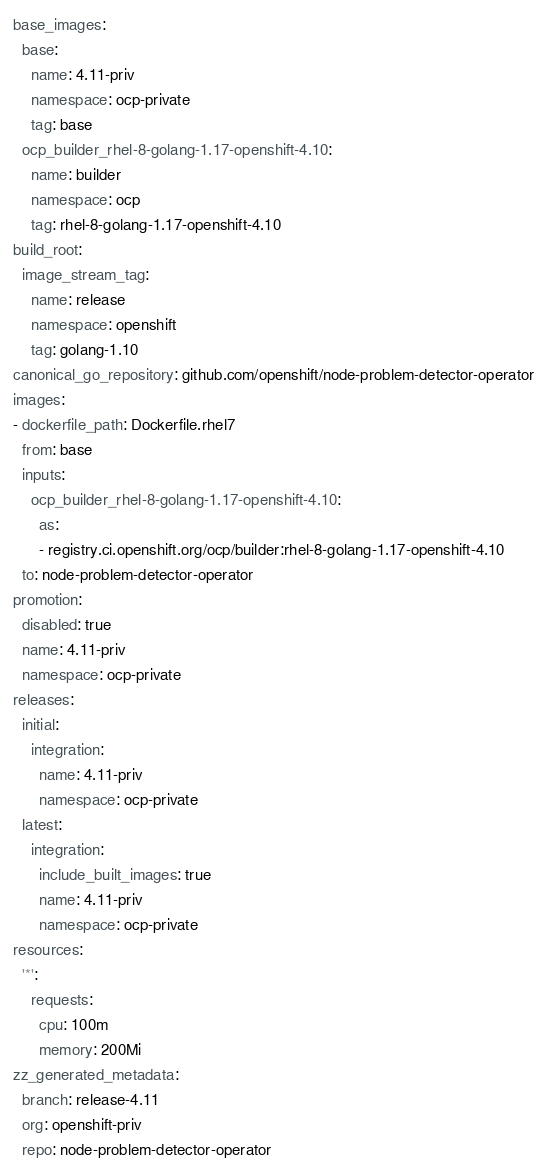Convert code to text. <code><loc_0><loc_0><loc_500><loc_500><_YAML_>base_images:
  base:
    name: 4.11-priv
    namespace: ocp-private
    tag: base
  ocp_builder_rhel-8-golang-1.17-openshift-4.10:
    name: builder
    namespace: ocp
    tag: rhel-8-golang-1.17-openshift-4.10
build_root:
  image_stream_tag:
    name: release
    namespace: openshift
    tag: golang-1.10
canonical_go_repository: github.com/openshift/node-problem-detector-operator
images:
- dockerfile_path: Dockerfile.rhel7
  from: base
  inputs:
    ocp_builder_rhel-8-golang-1.17-openshift-4.10:
      as:
      - registry.ci.openshift.org/ocp/builder:rhel-8-golang-1.17-openshift-4.10
  to: node-problem-detector-operator
promotion:
  disabled: true
  name: 4.11-priv
  namespace: ocp-private
releases:
  initial:
    integration:
      name: 4.11-priv
      namespace: ocp-private
  latest:
    integration:
      include_built_images: true
      name: 4.11-priv
      namespace: ocp-private
resources:
  '*':
    requests:
      cpu: 100m
      memory: 200Mi
zz_generated_metadata:
  branch: release-4.11
  org: openshift-priv
  repo: node-problem-detector-operator
</code> 